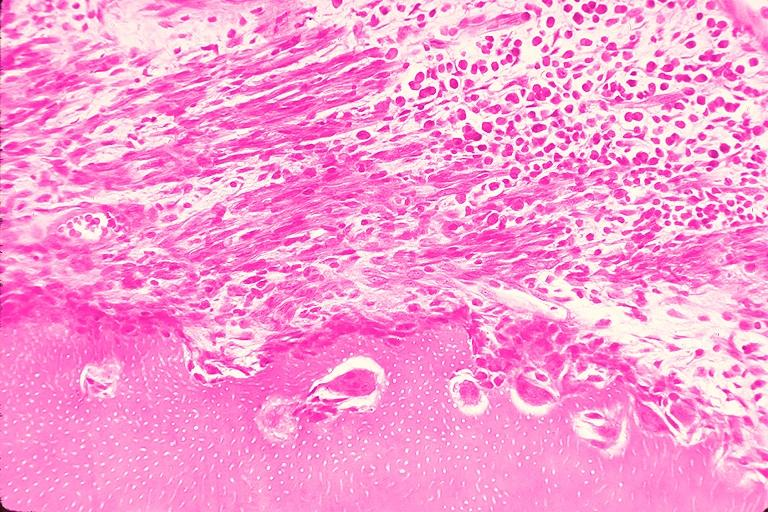where is this?
Answer the question using a single word or phrase. Oral 